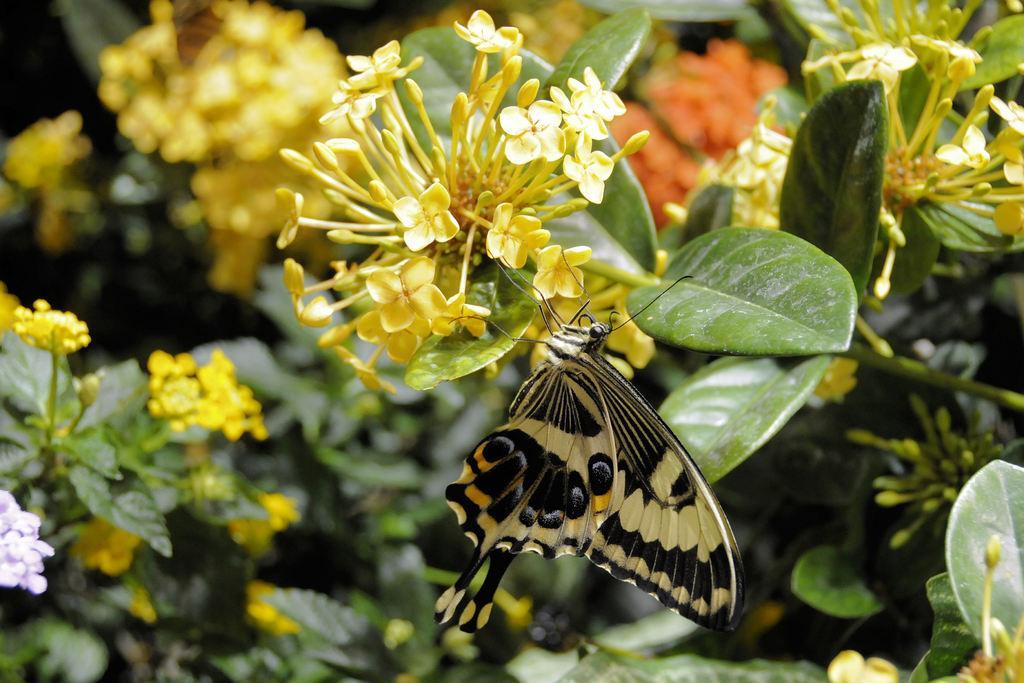Describe this image in one or two sentences. In this image we can see a black butterfly, there are wings, there is a plant and yellow flowers on it. 